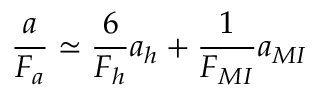<formula> <loc_0><loc_0><loc_500><loc_500>\frac { a } { F _ { a } } \simeq \frac { 6 } { F _ { h } } a _ { h } + \frac { 1 } { F _ { M I } } a _ { M I }</formula> 